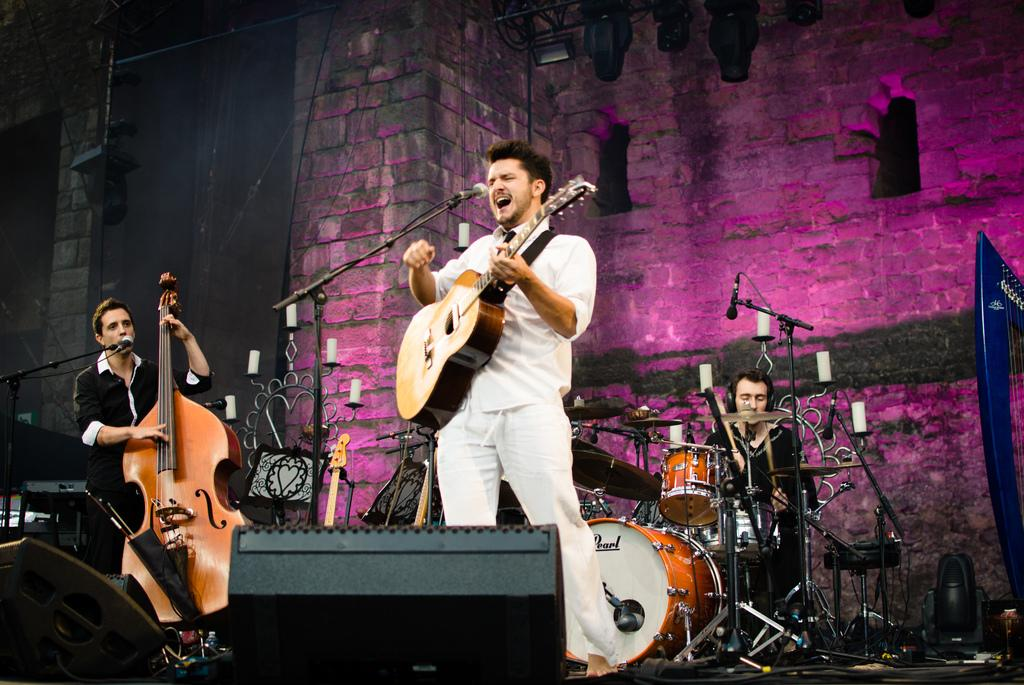What is the man in the image doing? The man is singing. What instrument is the man holding in the image? The man is holding a guitar. What type of produce can be seen in the image? There is no produce present in the image; it features a man singing and holding a guitar. What emotion does the man display while singing in the image? The provided facts do not mention the man's emotions while singing, so it cannot be determined from the image. 